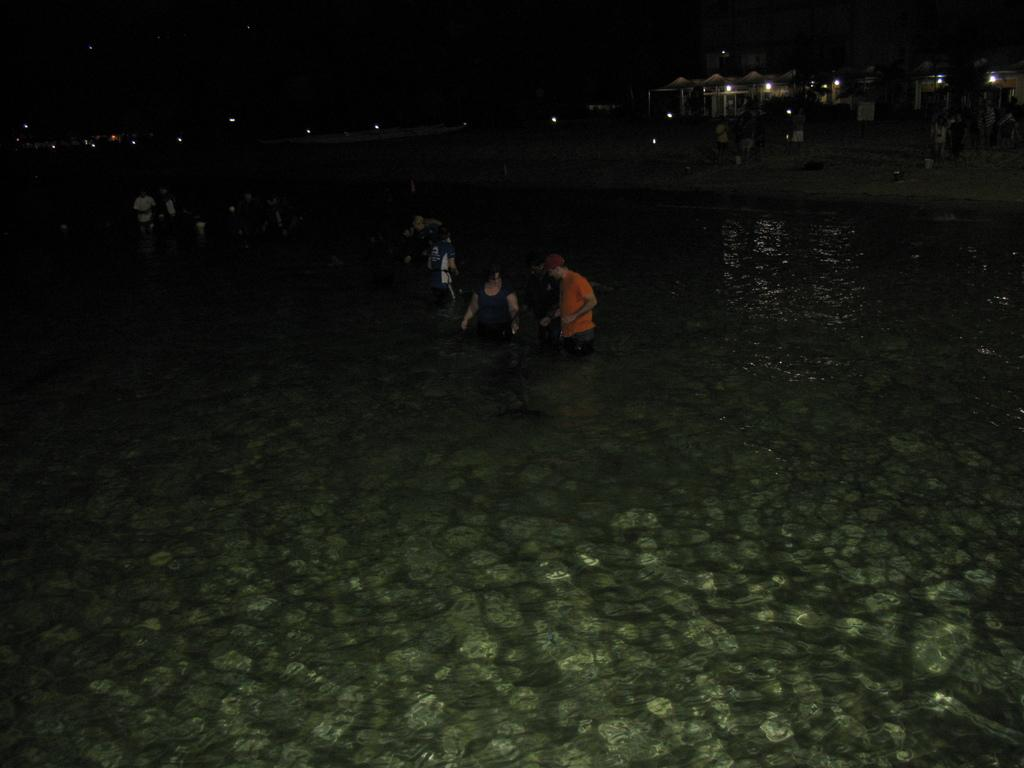What is at the bottom of the image? There is water at the bottom of the image. What can be seen in the image besides the water? There are people standing in the image. What is visible in the background of the image? There are buildings and lights visible in the background of the image. How would you describe the overall lighting in the image? The background of the image is dark. Where is the grandmother in the image? There is no grandmother present in the image. What type of sack is being used by the people in the image? There is no sack visible in the image. 